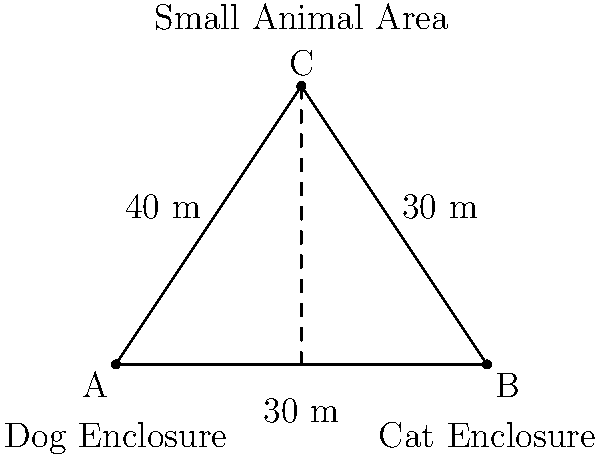At an animal rescue facility, three enclosures form a triangle: the Dog Enclosure (A), Cat Enclosure (B), and Small Animal Area (C). The distance between the Dog and Cat Enclosures is 60 meters. If the distance from the Small Animal Area to the Dog Enclosure is 40 meters, and to the Cat Enclosure is 30 meters, what is the area of the triangular region formed by these three enclosures? To find the area of the triangular region, we can use Heron's formula. Let's approach this step-by-step:

1) First, let's identify the sides of the triangle:
   AB = 60 m (given)
   AC = 40 m (given)
   BC = 30 m (given)

2) Heron's formula states that the area of a triangle with sides a, b, and c is:
   $$ A = \sqrt{s(s-a)(s-b)(s-c)} $$
   where s is the semi-perimeter: $s = \frac{a+b+c}{2}$

3) Calculate the semi-perimeter:
   $$ s = \frac{60 + 40 + 30}{2} = \frac{130}{2} = 65 \text{ m} $$

4) Now, let's substitute these values into Heron's formula:
   $$ A = \sqrt{65(65-60)(65-40)(65-30)} $$
   $$ A = \sqrt{65 \cdot 5 \cdot 25 \cdot 35} $$

5) Simplify under the square root:
   $$ A = \sqrt{284,375} $$

6) Calculate the square root:
   $$ A \approx 533.27 \text{ m}^2 $$

Therefore, the area of the triangular region formed by the three enclosures is approximately 533.27 square meters.
Answer: 533.27 m² 